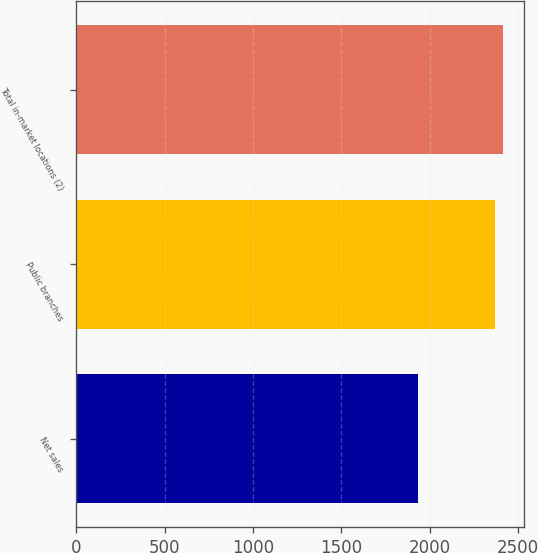Convert chart. <chart><loc_0><loc_0><loc_500><loc_500><bar_chart><fcel>Net sales<fcel>Public branches<fcel>Total in-market locations (2)<nl><fcel>1930.3<fcel>2369<fcel>2412.87<nl></chart> 